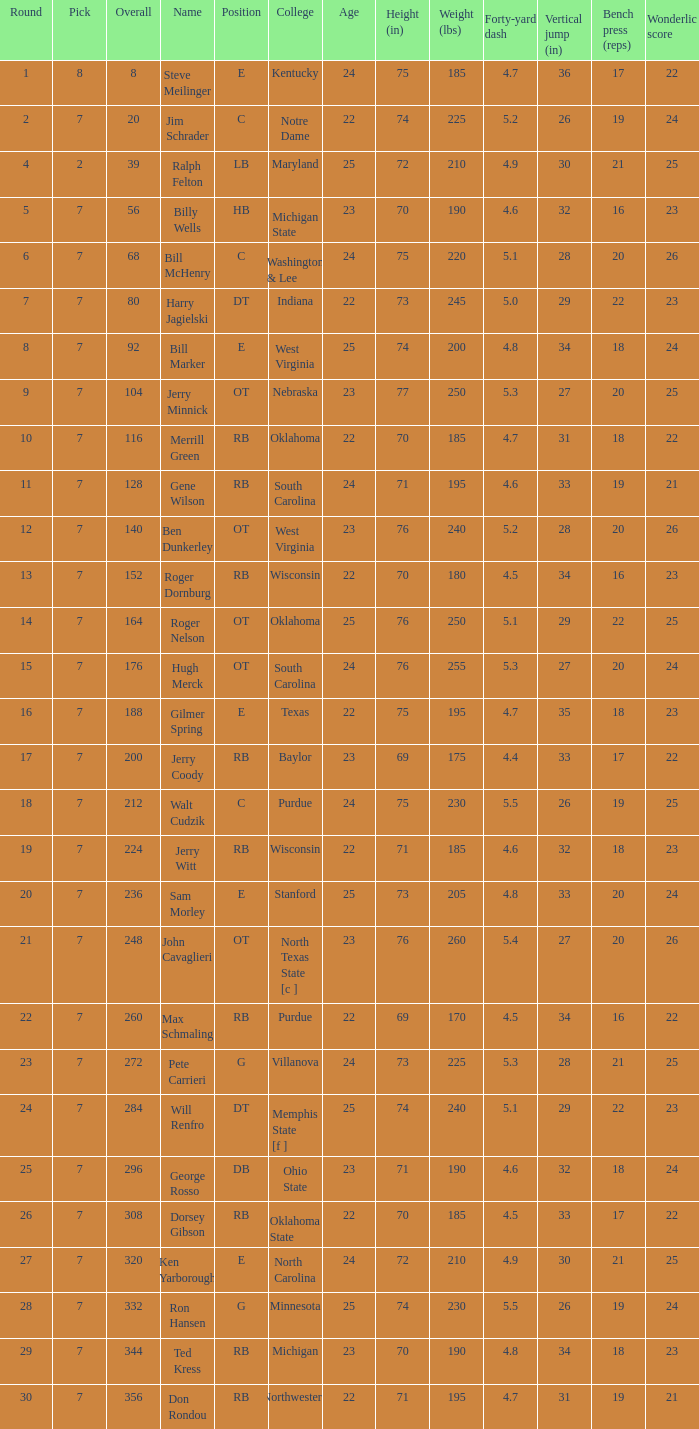What pick did George Rosso get drafted when the overall was less than 296? 0.0. 